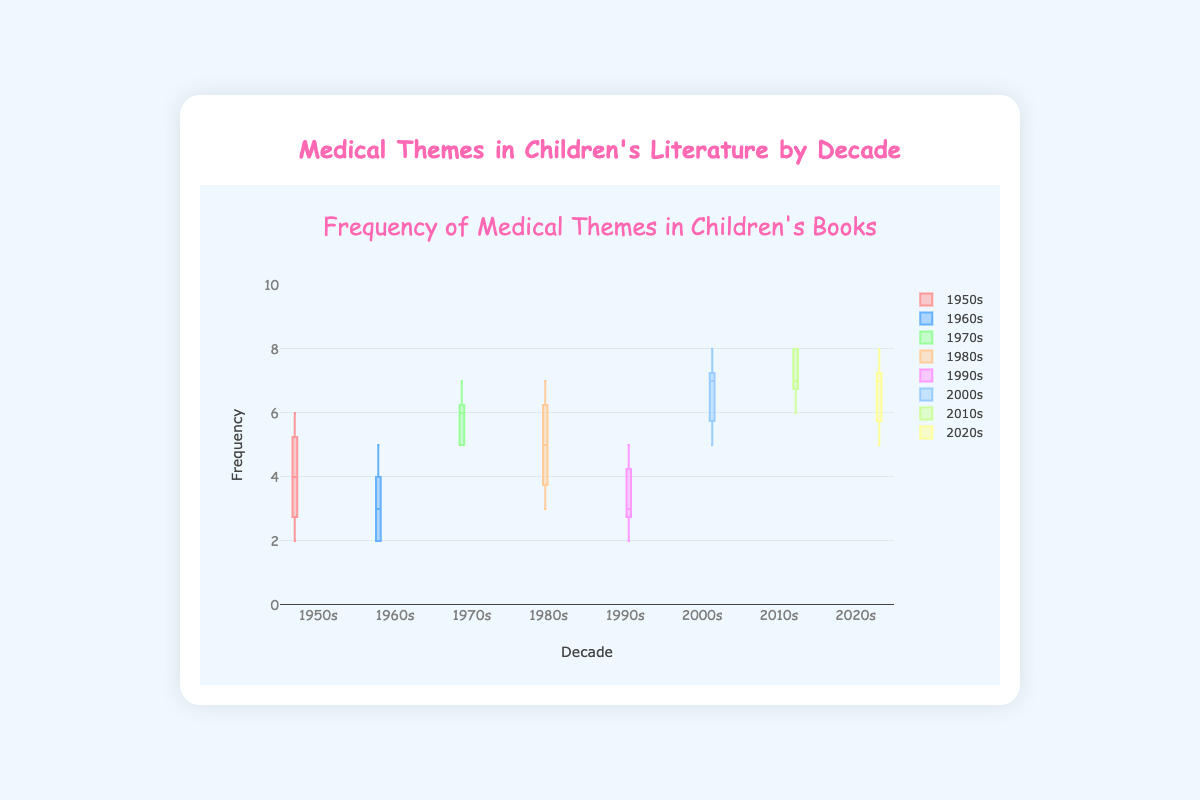What is the color of the box plot for the 1950s? To identify this, look at the box representing the 1950s decade in the figure and note its color.
Answer: Pink What's the range of values for the 2010s? Look at the minimum and maximum values of the box plot for the 2010s. The minimum is 6 and the maximum is 8.
Answer: 6 to 8 Which decade has the highest median frequency of medical themes? Compare the median lines of each box plot. The 2010s and 2020s seem to have the highest medians at 7.
Answer: 2010s and 2020s How does the frequency of medical themes in the 1970s compare to that in the 1960s? Compare the position of the boxes for the two decades. The 1970s box plot is higher compared to the 1960s.
Answer: Higher in the 1970s What is the interquartile range (IQR) for the 1980s? The IQR is the difference between the 75th percentile and the 25th percentile. For the 1980s, the 75th percentile is 6 and the 25th percentile is 4, so the IQR is 6 - 4.
Answer: 2 Which decade shows the most variability in frequency of medical themes? The decade with the broadest box (largest range from minimum to maximum) represents the most variability. This appears to be the 2000s.
Answer: 2000s What can you infer about the trend of medical themes over the decades? Observe the medians and the range of each decade's box plot. There's an increasing trend in the median values, indicating a rise in the frequency of medical themes over time.
Answer: Increasing How many data points are there in the 1990s box plot? Count the number of individual points listed for the 1990s.
Answer: 5 What decade has the lowest minimum value and what is it? Look for the lowest whisker across all box plots. The 1960s have the lowest minimum value at 2.
Answer: 1960s, 2 Are there any outliers in the data? For outliers, check if there are any individual points outside the whiskers of the boxplots. None of the boxplots show points outside the whiskers.
Answer: No 